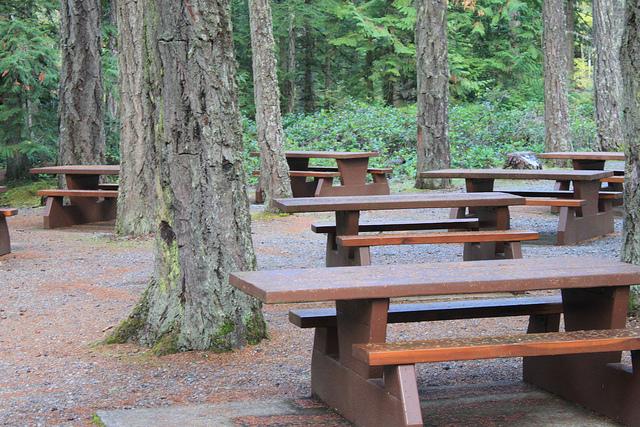How many tables are empty?
Answer briefly. 6. What are the tables used for?
Give a very brief answer. Picnics. Is anyone sitting at the tables?
Be succinct. No. 